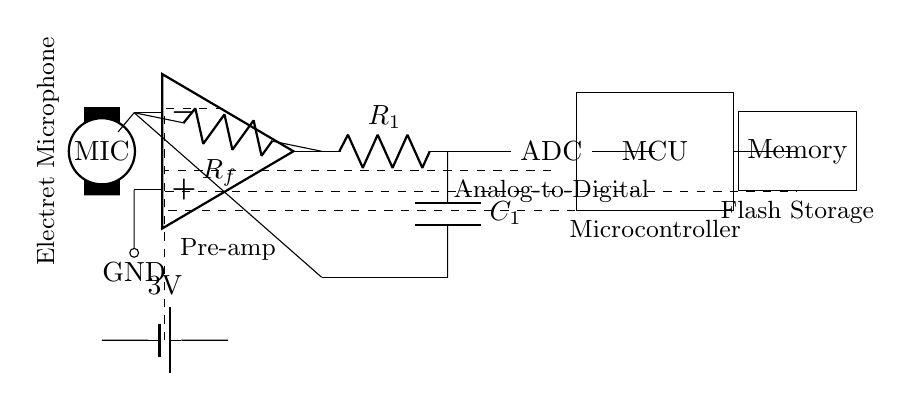What type of microphone is used in this circuit? The circuit specifies an electret microphone, which is commonly used for audio applications due to its sensitivity and small size.
Answer: Electret Microphone What is the function of the amplifier in this circuit? The amplifier, labeled as pre-amp, is used to boost the electrical signal from the microphone to a level suitable for processing.
Answer: Pre-amp How many components are involved in the signal processing section of the circuit? The signal processing section includes the microphone, amplifier, ADC, and microcontroller, totaling four main components involved in converting audio signals.
Answer: Four What is the voltage provided by the battery in this circuit? The circuit diagram indicates a power source labeled as a battery with a voltage of 3V, which powers the entire circuit.
Answer: 3V Why is a low-pass filter used in this circuit? A low-pass filter, consisting of a resistor and capacitor, is included to remove high-frequency noise from the audio signal, ensuring the quality of the recorded sound.
Answer: To remove high-frequency noise Which component converts the analog audio signal to digital? The ADC (Analog-to-Digital Converter) is responsible for converting the analog audio signal from the microphone into digital form for processing by the microcontroller.
Answer: ADC What type of storage is utilized in the circuit for recording? The memory component shown in the circuit is used for flash storage, which is suitable for recording audio data in a compact manner.
Answer: Flash Storage 